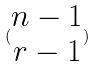Convert formula to latex. <formula><loc_0><loc_0><loc_500><loc_500>( \begin{matrix} n - 1 \\ r - 1 \end{matrix} )</formula> 